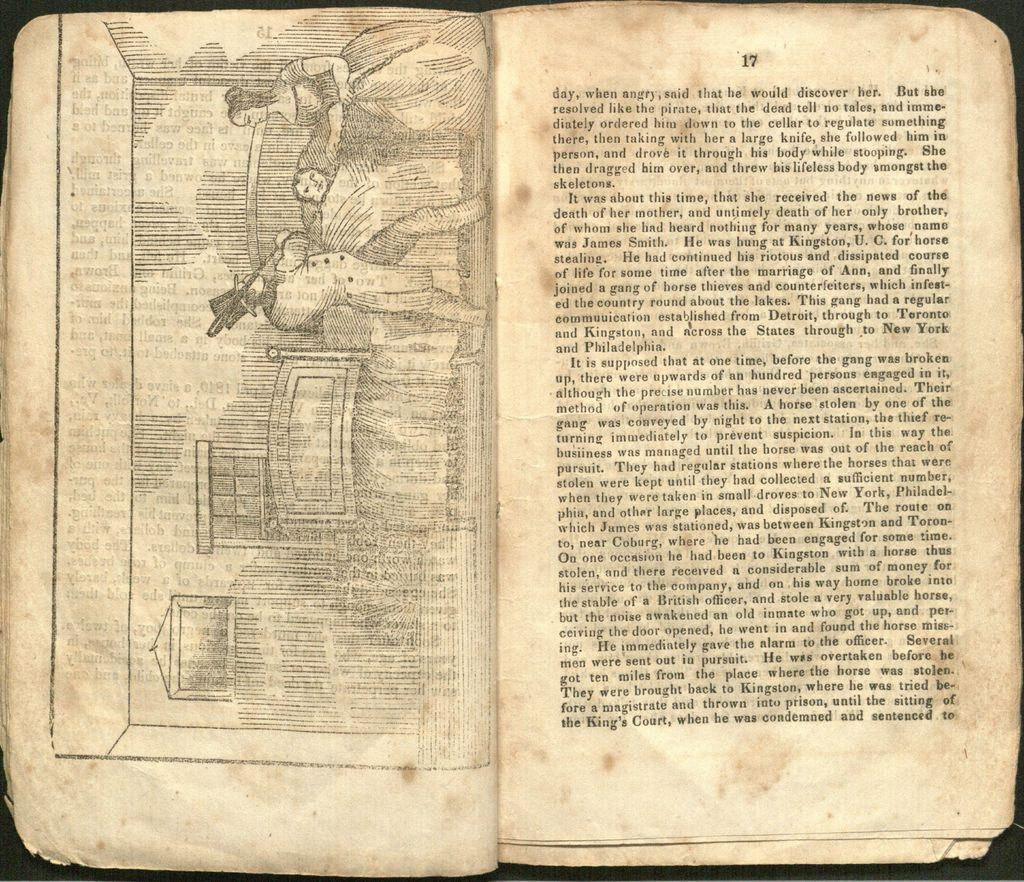<image>
Summarize the visual content of the image. An old book is opened to page seventeen. 